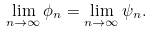Convert formula to latex. <formula><loc_0><loc_0><loc_500><loc_500>\lim _ { n \to \infty } \phi _ { n } = \lim _ { n \to \infty } \psi _ { n } .</formula> 